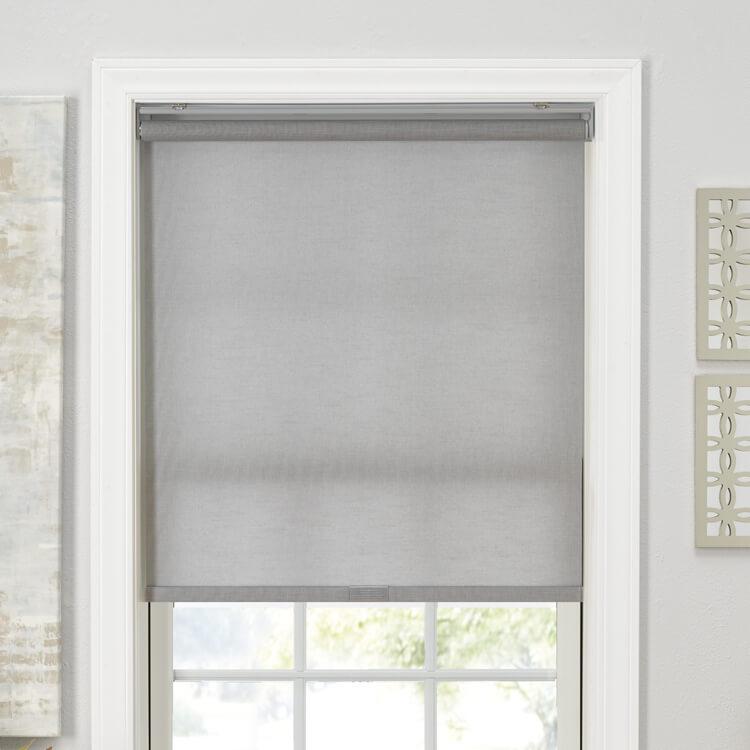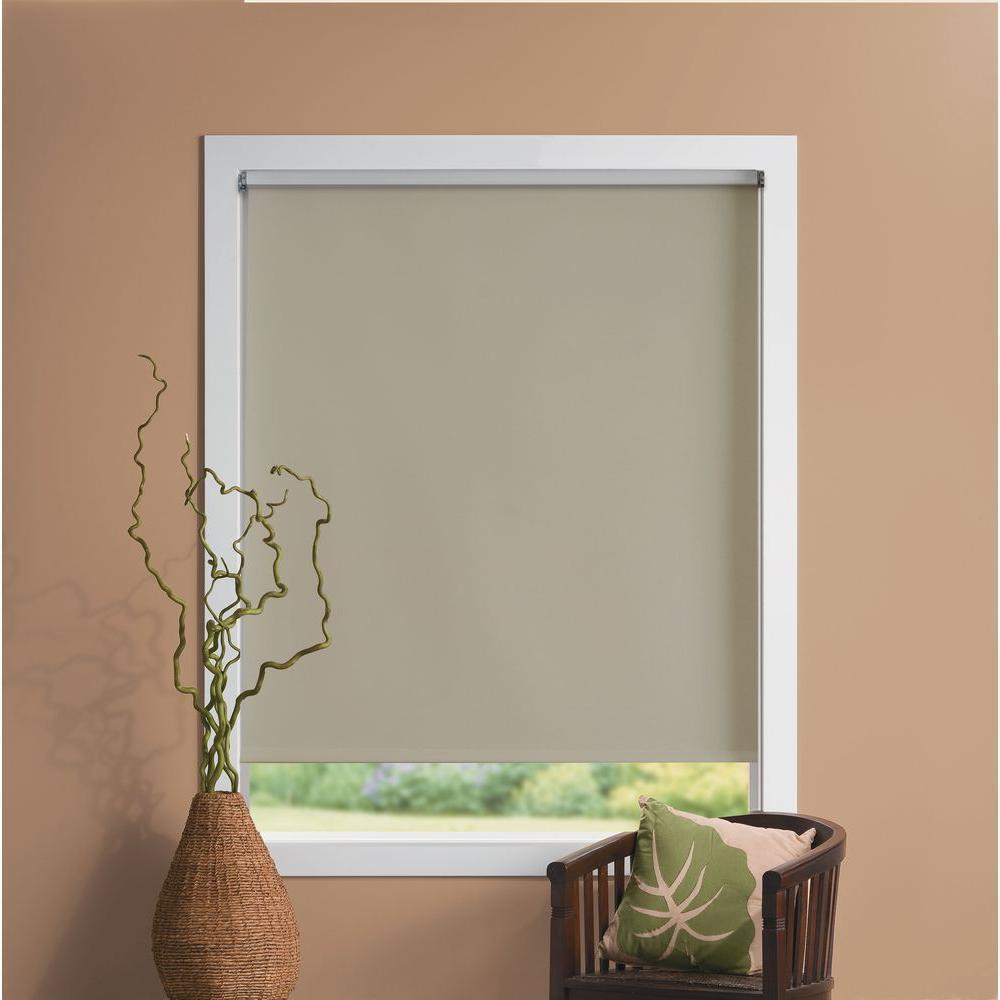The first image is the image on the left, the second image is the image on the right. Evaluate the accuracy of this statement regarding the images: "There are exactly two window shades.". Is it true? Answer yes or no. Yes. The first image is the image on the left, the second image is the image on the right. Evaluate the accuracy of this statement regarding the images: "A single brown chair is located near a window with a shade in the image on the right.". Is it true? Answer yes or no. Yes. 